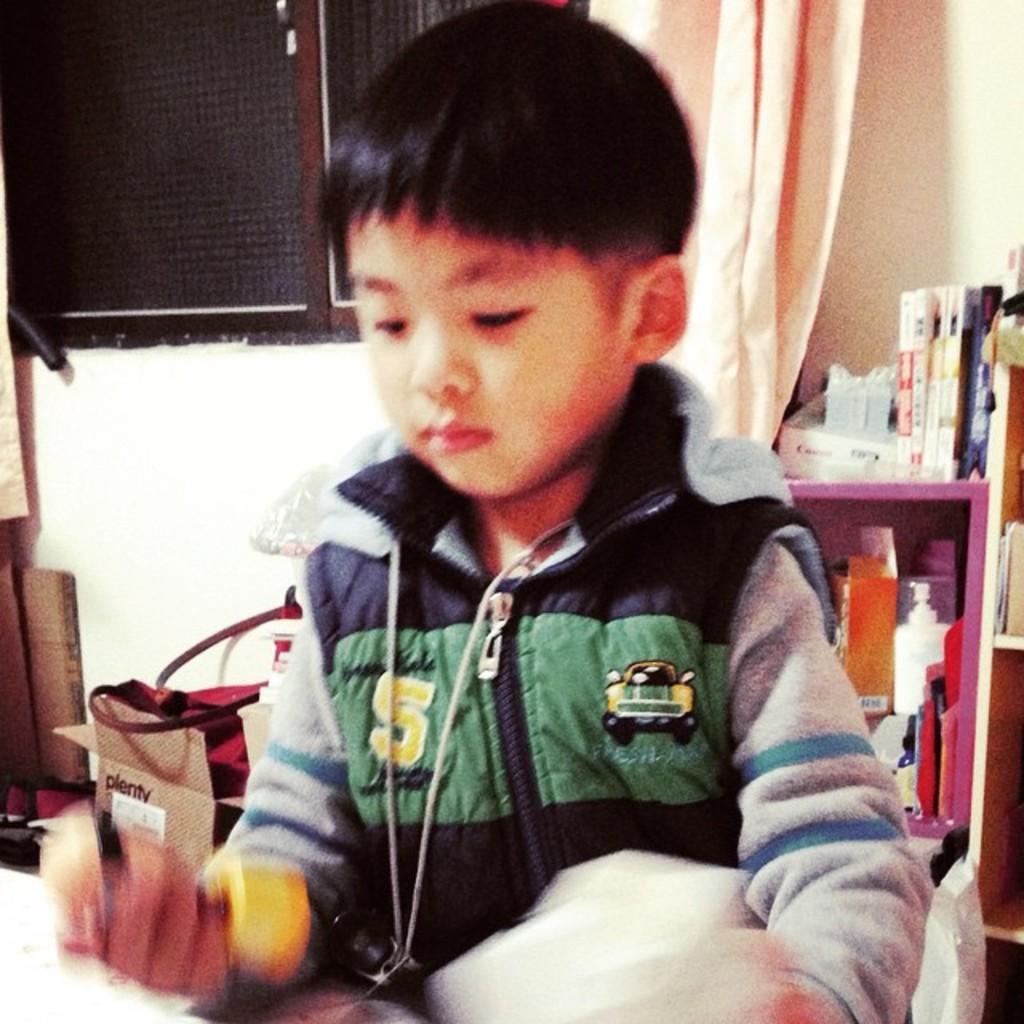How would you summarize this image in a sentence or two? In this image we can see a kid wearing sweater sitting and holding some objects in his hands and at the background of the image there are some objects in the shelves, books, at the left side of the image there are some bags and at the background of the image there is window and curtain. 